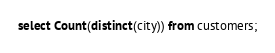<code> <loc_0><loc_0><loc_500><loc_500><_SQL_>select Count(distinct(city)) from customers;
</code> 